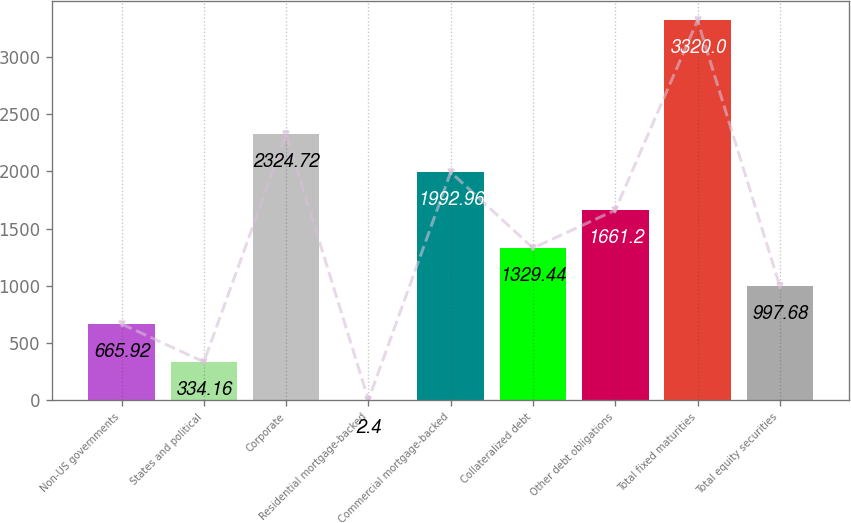<chart> <loc_0><loc_0><loc_500><loc_500><bar_chart><fcel>Non-US governments<fcel>States and political<fcel>Corporate<fcel>Residential mortgage-backed<fcel>Commercial mortgage-backed<fcel>Collateralized debt<fcel>Other debt obligations<fcel>Total fixed maturities<fcel>Total equity securities<nl><fcel>665.92<fcel>334.16<fcel>2324.72<fcel>2.4<fcel>1992.96<fcel>1329.44<fcel>1661.2<fcel>3320<fcel>997.68<nl></chart> 